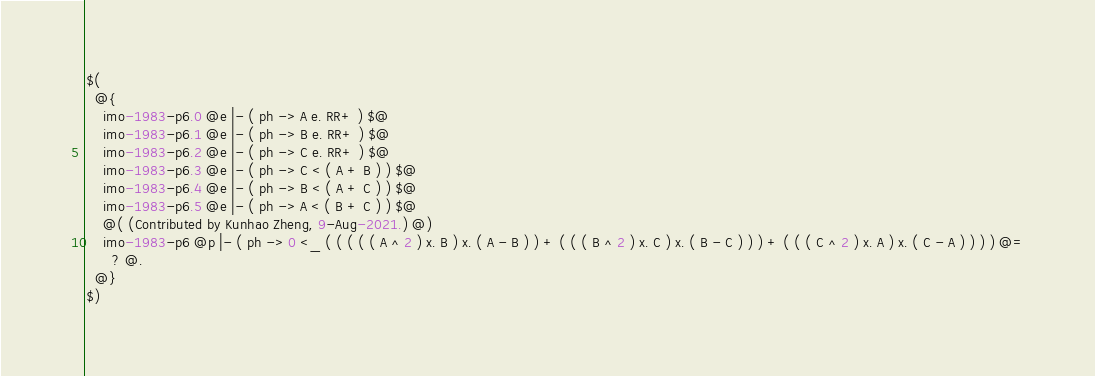Convert code to text. <code><loc_0><loc_0><loc_500><loc_500><_ObjectiveC_>$(
  @{
    imo-1983-p6.0 @e |- ( ph -> A e. RR+ ) $@
    imo-1983-p6.1 @e |- ( ph -> B e. RR+ ) $@
    imo-1983-p6.2 @e |- ( ph -> C e. RR+ ) $@
    imo-1983-p6.3 @e |- ( ph -> C < ( A + B ) ) $@
    imo-1983-p6.4 @e |- ( ph -> B < ( A + C ) ) $@
    imo-1983-p6.5 @e |- ( ph -> A < ( B + C ) ) $@
    @( (Contributed by Kunhao Zheng, 9-Aug-2021.) @)
    imo-1983-p6 @p |- ( ph -> 0 <_ ( ( ( ( ( A ^ 2 ) x. B ) x. ( A - B ) ) + ( ( ( B ^ 2 ) x. C ) x. ( B - C ) ) ) + ( ( ( C ^ 2 ) x. A ) x. ( C - A ) ) ) ) @=
      ? @.
  @}
$)
</code> 